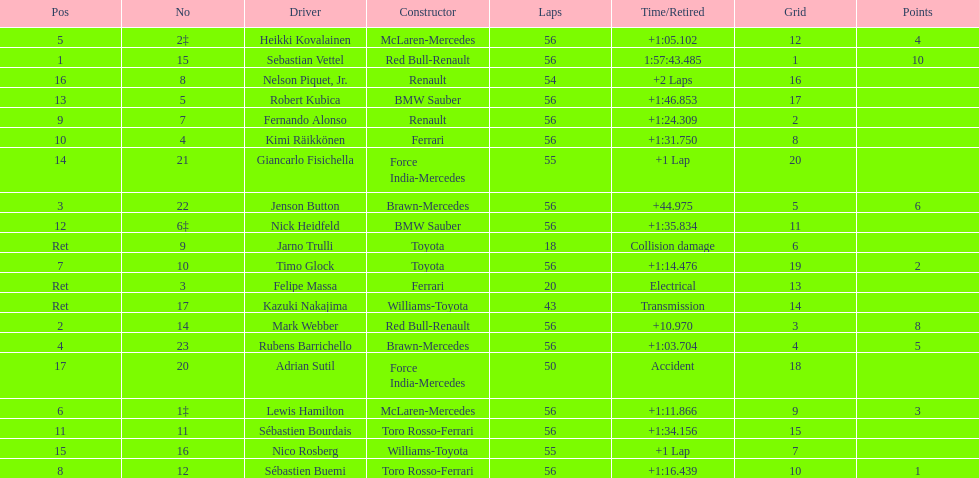Heikki kovalainen and lewis hamilton both had which constructor? McLaren-Mercedes. 